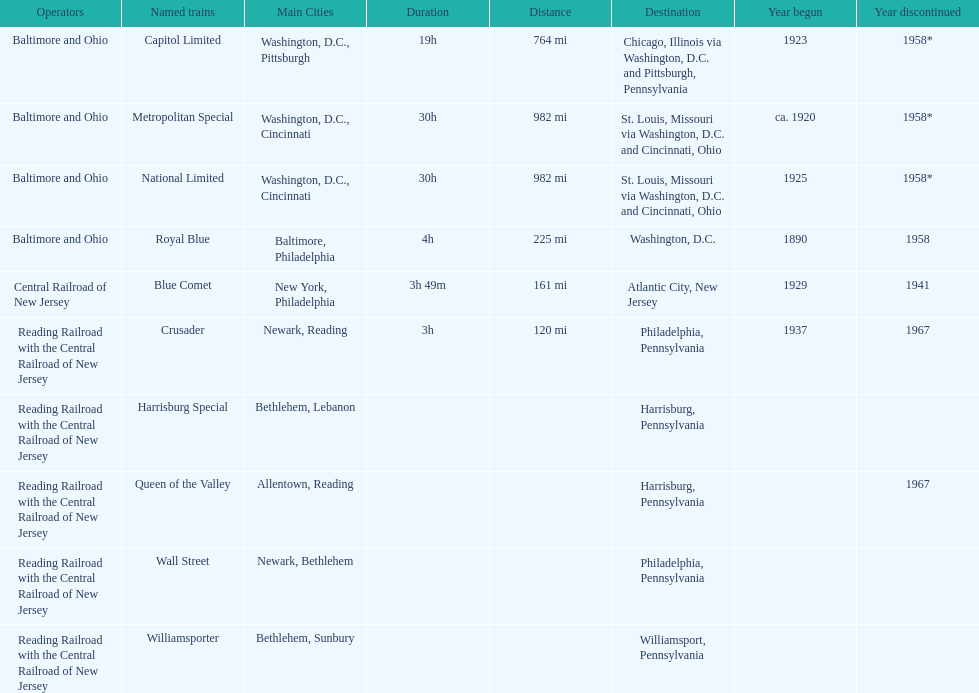What was the first train to begin service? Royal Blue. 